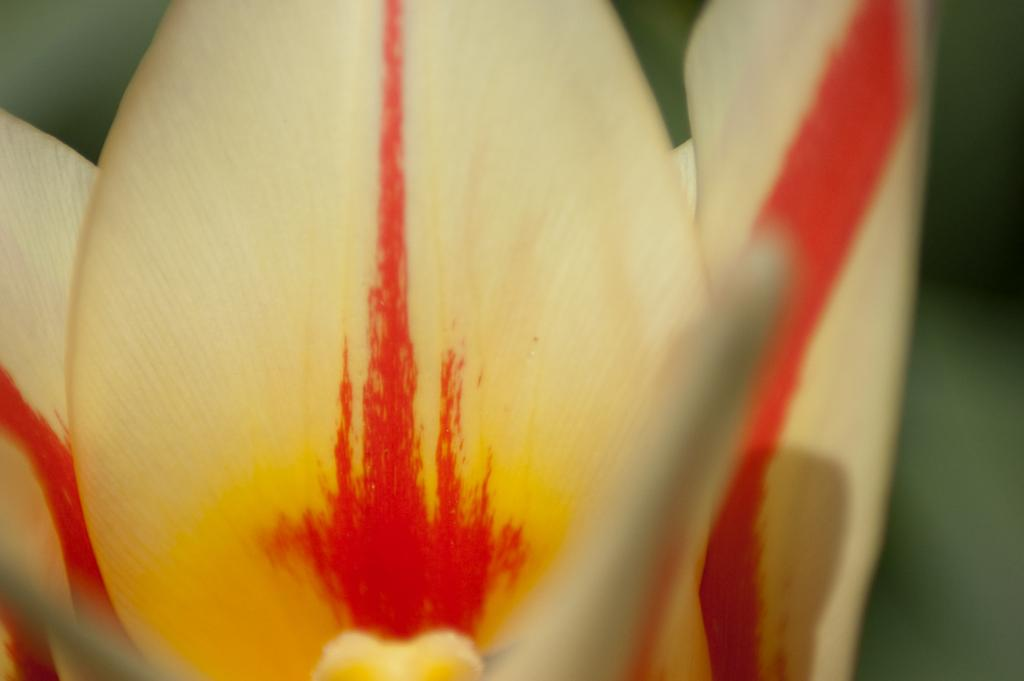What is the main subject in the foreground of the image? There is a flower in the foreground of the image. Can you describe the colors of the flower? The flower has red and yellow colors. What type of business does the flower achieve in the image? The image does not depict any business or achievement related to the flower. 